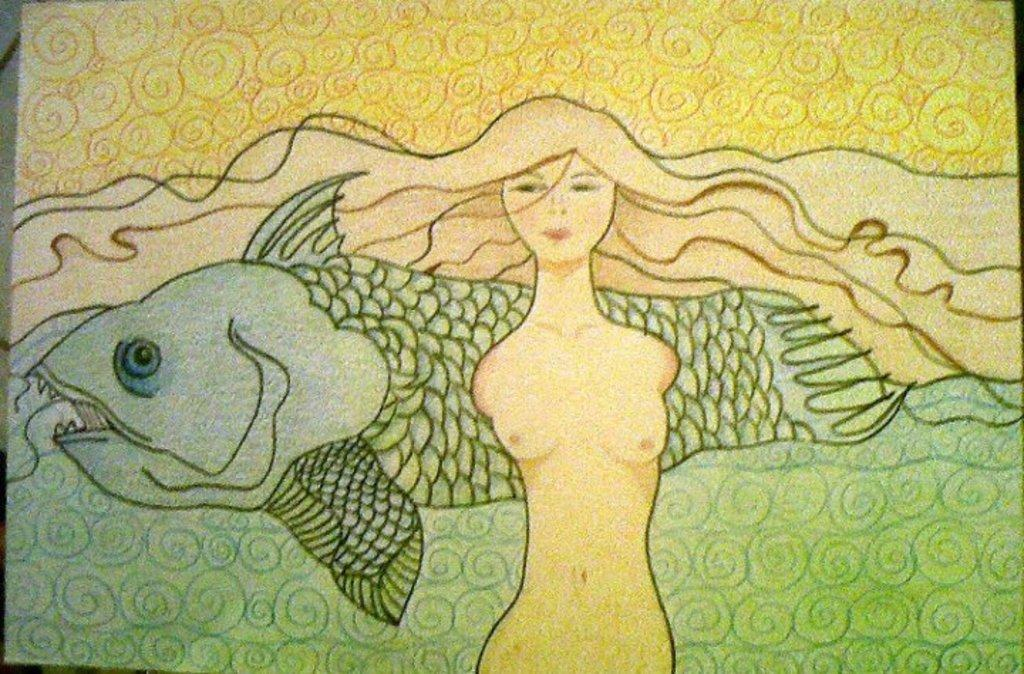What is the main subject of the image? There is a depiction of a woman in the image. What type of food is the woman holding in the image? There is no food present in the image; it only depicts a woman. What type of cushion is the woman sitting on in the image? There is no cushion or indication of the woman sitting in the image; it only depicts her standing. 